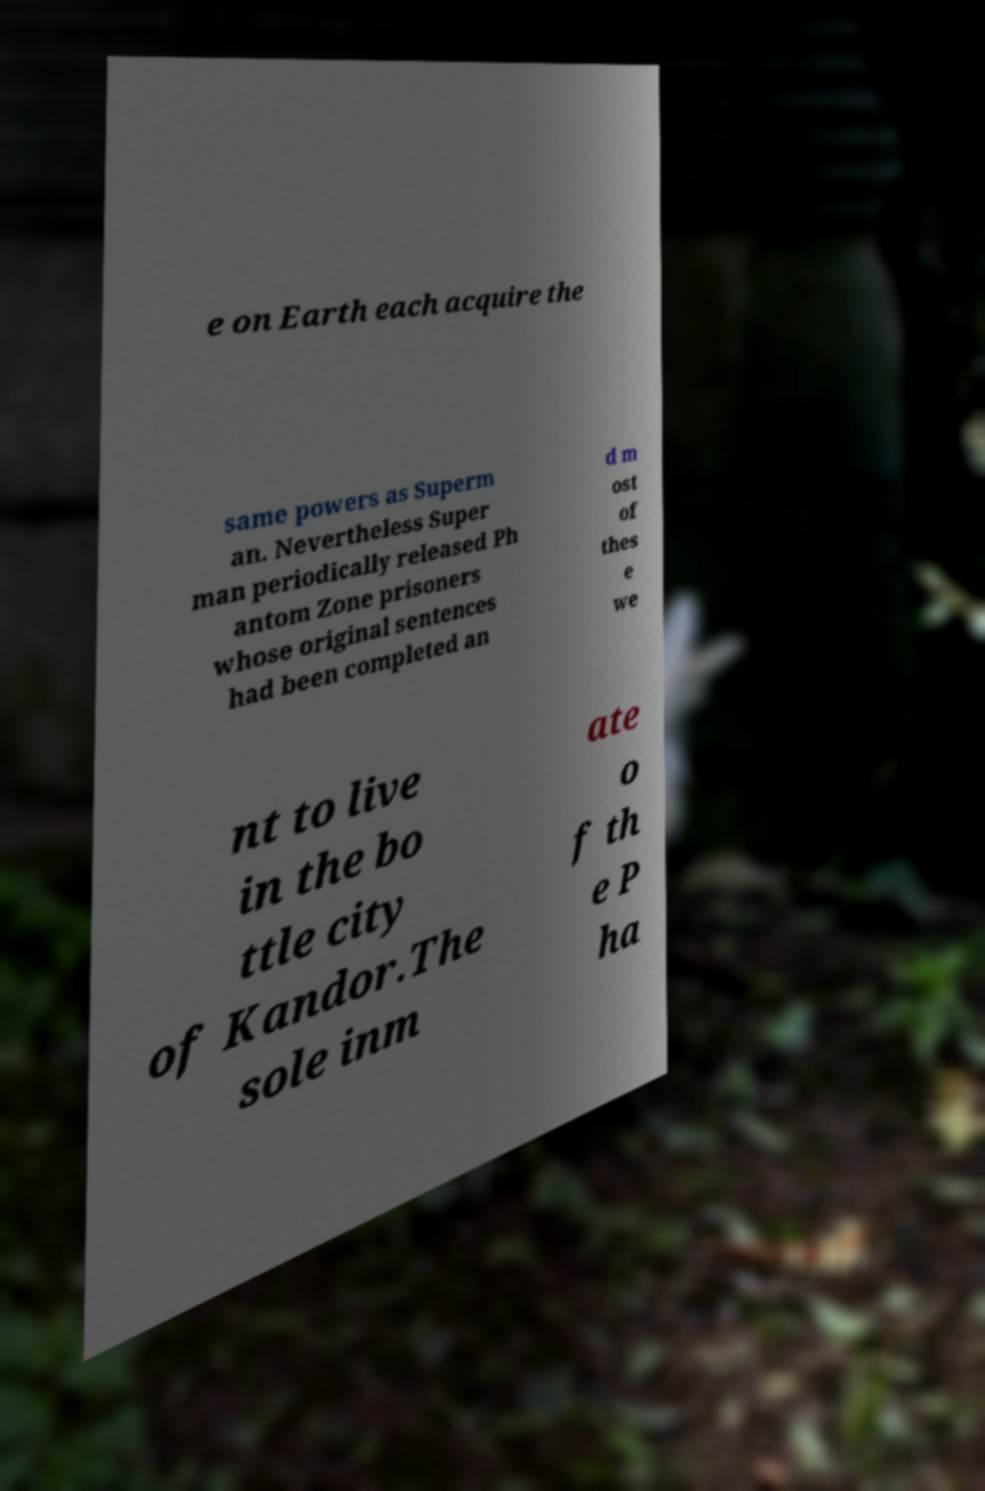Can you accurately transcribe the text from the provided image for me? e on Earth each acquire the same powers as Superm an. Nevertheless Super man periodically released Ph antom Zone prisoners whose original sentences had been completed an d m ost of thes e we nt to live in the bo ttle city of Kandor.The sole inm ate o f th e P ha 